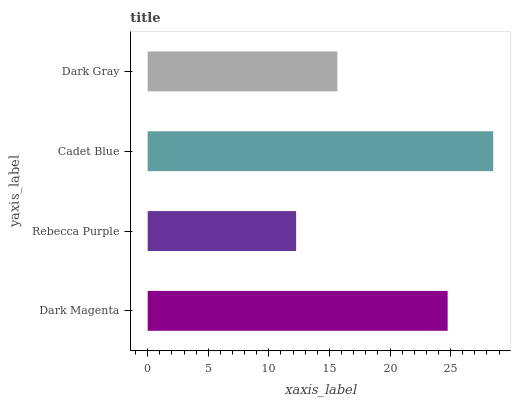Is Rebecca Purple the minimum?
Answer yes or no. Yes. Is Cadet Blue the maximum?
Answer yes or no. Yes. Is Cadet Blue the minimum?
Answer yes or no. No. Is Rebecca Purple the maximum?
Answer yes or no. No. Is Cadet Blue greater than Rebecca Purple?
Answer yes or no. Yes. Is Rebecca Purple less than Cadet Blue?
Answer yes or no. Yes. Is Rebecca Purple greater than Cadet Blue?
Answer yes or no. No. Is Cadet Blue less than Rebecca Purple?
Answer yes or no. No. Is Dark Magenta the high median?
Answer yes or no. Yes. Is Dark Gray the low median?
Answer yes or no. Yes. Is Rebecca Purple the high median?
Answer yes or no. No. Is Rebecca Purple the low median?
Answer yes or no. No. 